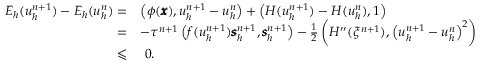<formula> <loc_0><loc_0><loc_500><loc_500>\begin{array} { r l } { { E } _ { h } ( u _ { h } ^ { n + 1 } ) - { E } _ { h } ( u _ { h } ^ { n } ) = } & { \left ( \phi ( \pm b { x } ) , u _ { h } ^ { n + 1 } - u _ { h } ^ { n } \right ) + \left ( H ( u _ { h } ^ { n + 1 } ) - H ( u _ { h } ^ { n } ) , 1 \right ) } \\ { = } & { - \tau ^ { n + 1 } \left ( f ( u _ { h } ^ { n + 1 } ) \pm b { s } _ { h } ^ { n + 1 } , \pm b { s } _ { h } ^ { n + 1 } \right ) - \frac { 1 } { 2 } \left ( H ^ { \prime \prime } ( \xi ^ { n + 1 } ) , \left ( u _ { h } ^ { n + 1 } - u _ { h } ^ { n } \right ) ^ { 2 } \right ) } \\ { \leqslant } & { \ 0 . } \end{array}</formula> 